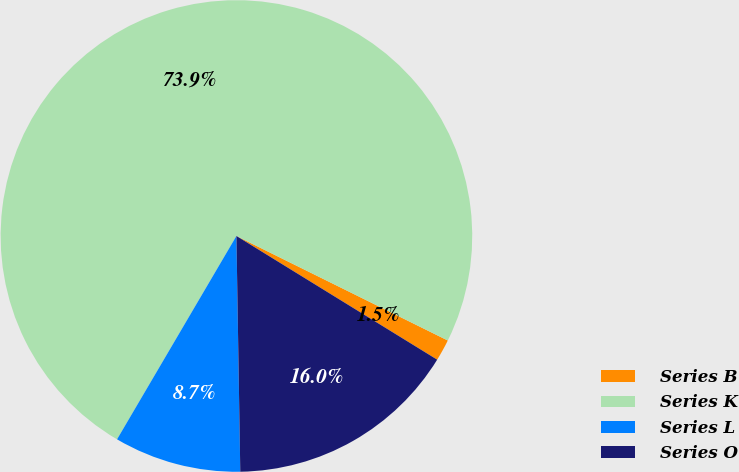Convert chart. <chart><loc_0><loc_0><loc_500><loc_500><pie_chart><fcel>Series B<fcel>Series K<fcel>Series L<fcel>Series O<nl><fcel>1.48%<fcel>73.86%<fcel>8.71%<fcel>15.95%<nl></chart> 